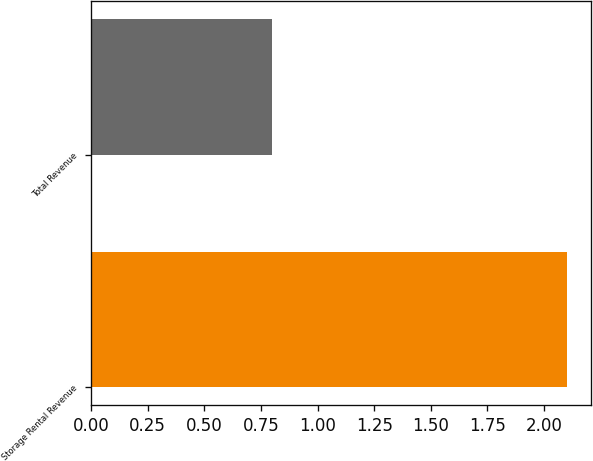Convert chart. <chart><loc_0><loc_0><loc_500><loc_500><bar_chart><fcel>Storage Rental Revenue<fcel>Total Revenue<nl><fcel>2.1<fcel>0.8<nl></chart> 